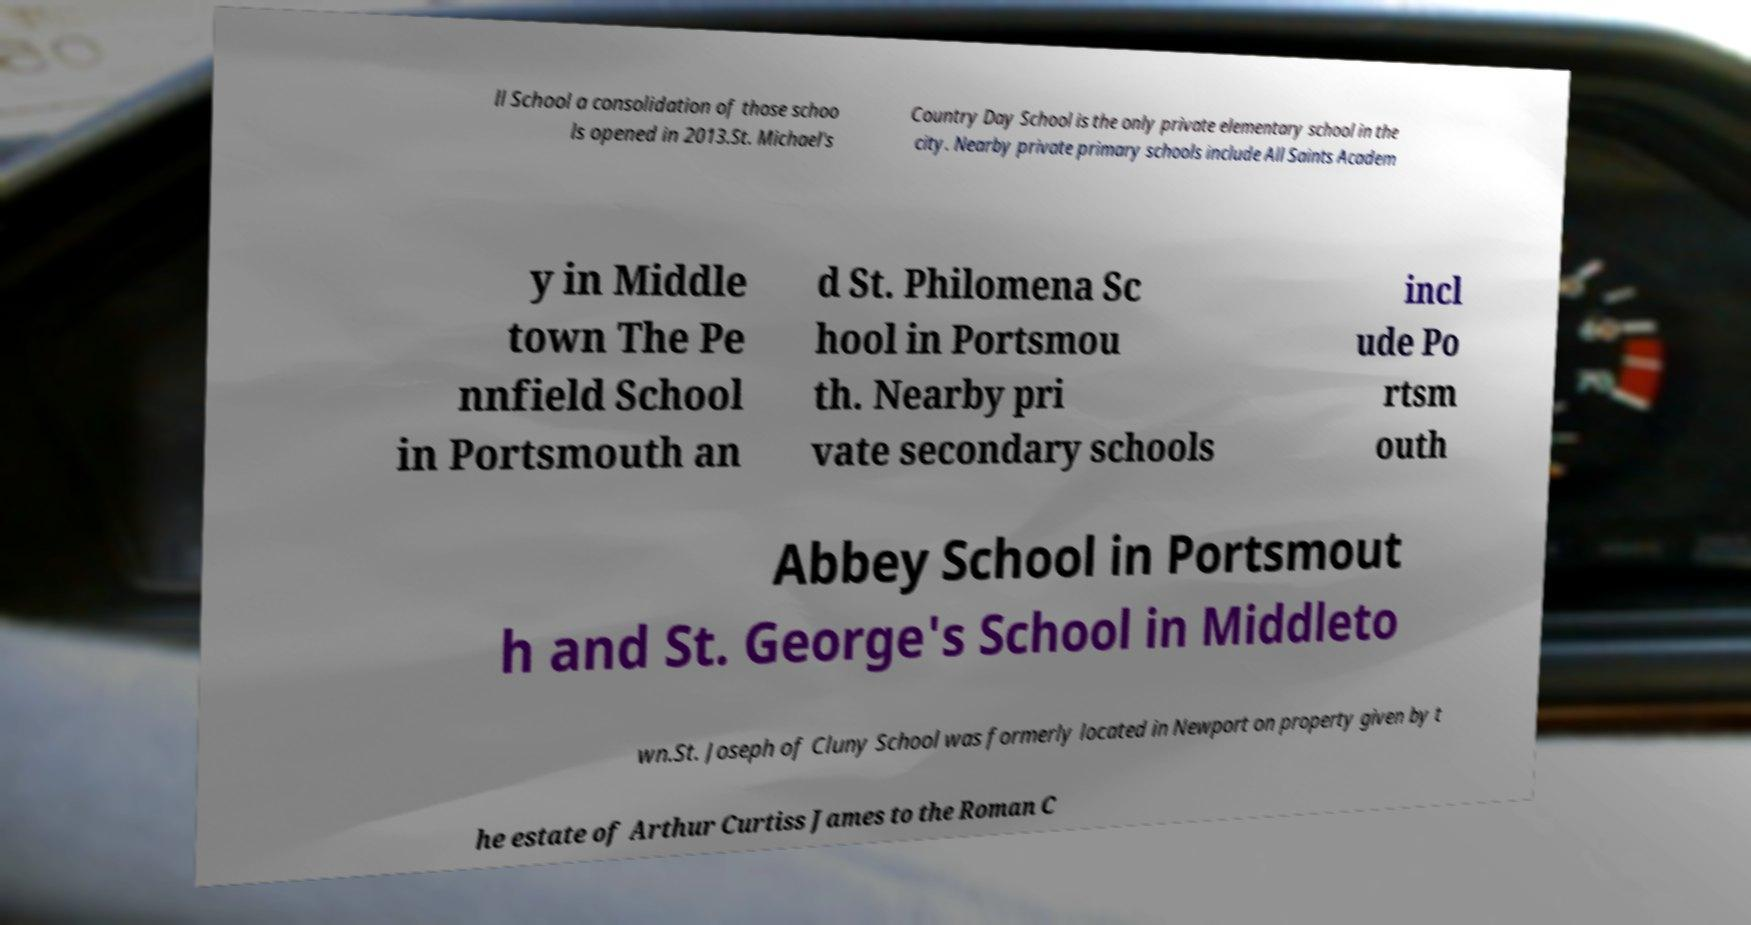Could you assist in decoding the text presented in this image and type it out clearly? ll School a consolidation of those schoo ls opened in 2013.St. Michael's Country Day School is the only private elementary school in the city. Nearby private primary schools include All Saints Academ y in Middle town The Pe nnfield School in Portsmouth an d St. Philomena Sc hool in Portsmou th. Nearby pri vate secondary schools incl ude Po rtsm outh Abbey School in Portsmout h and St. George's School in Middleto wn.St. Joseph of Cluny School was formerly located in Newport on property given by t he estate of Arthur Curtiss James to the Roman C 